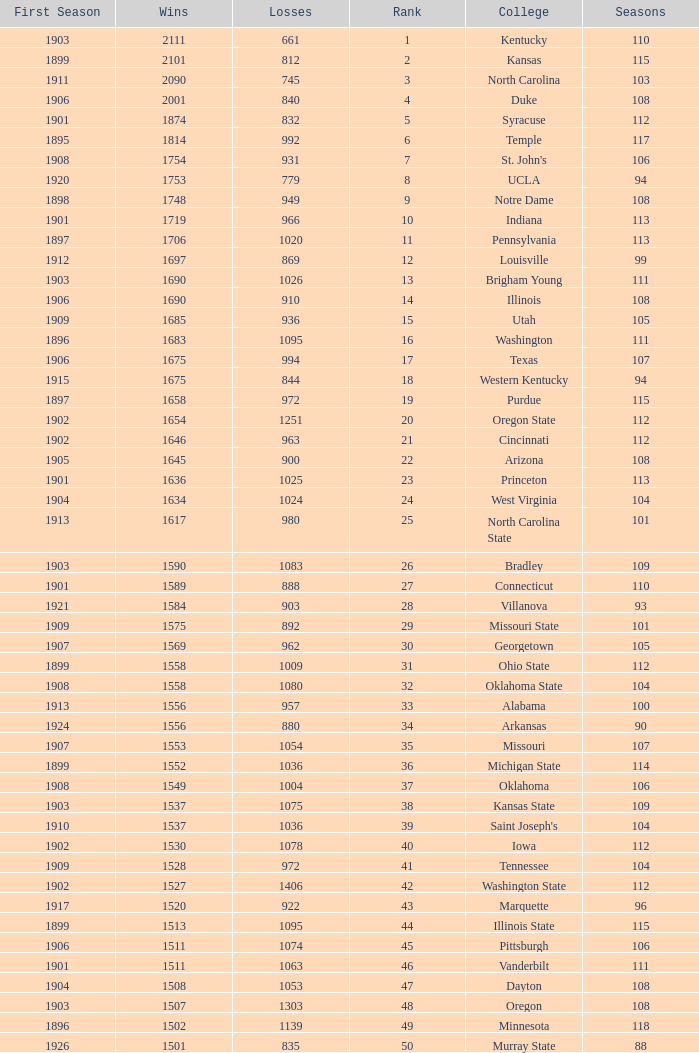What is the total number of rank with losses less than 992, North Carolina State College and a season greater than 101? 0.0. 